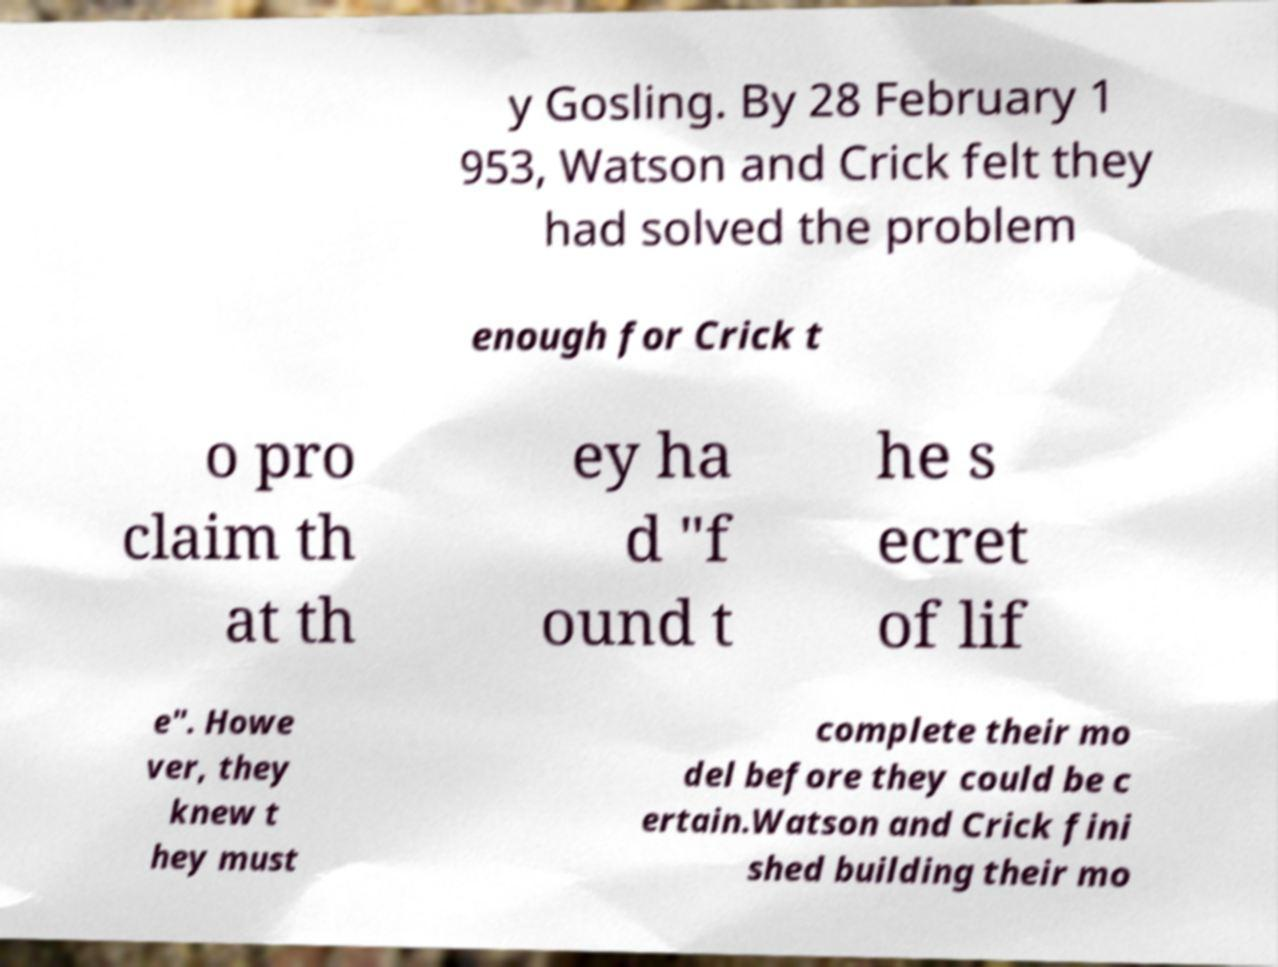Can you read and provide the text displayed in the image?This photo seems to have some interesting text. Can you extract and type it out for me? y Gosling. By 28 February 1 953, Watson and Crick felt they had solved the problem enough for Crick t o pro claim th at th ey ha d "f ound t he s ecret of lif e". Howe ver, they knew t hey must complete their mo del before they could be c ertain.Watson and Crick fini shed building their mo 